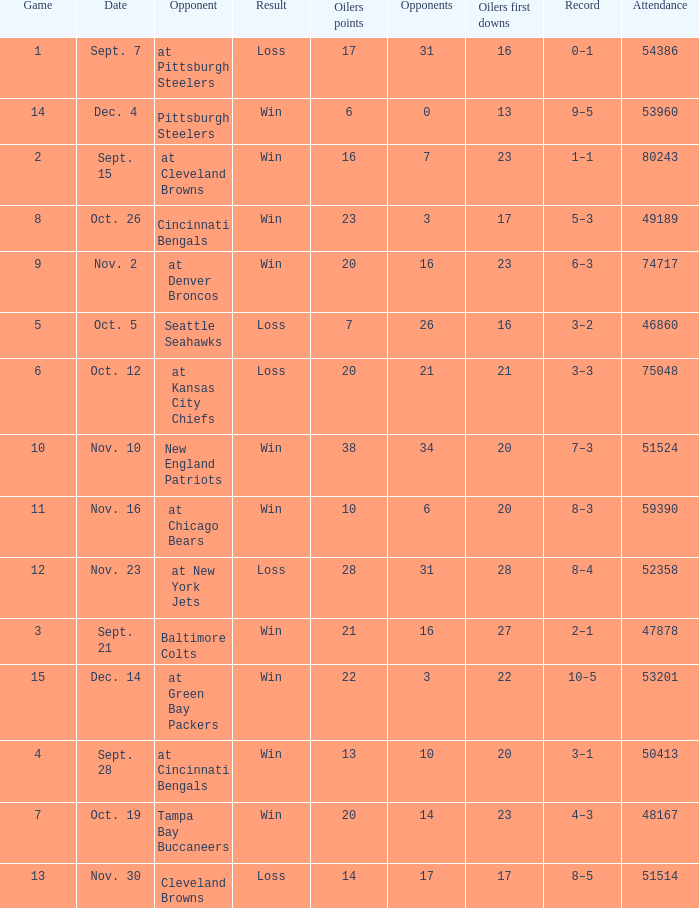Parse the full table. {'header': ['Game', 'Date', 'Opponent', 'Result', 'Oilers points', 'Opponents', 'Oilers first downs', 'Record', 'Attendance'], 'rows': [['1', 'Sept. 7', 'at Pittsburgh Steelers', 'Loss', '17', '31', '16', '0–1', '54386'], ['14', 'Dec. 4', 'Pittsburgh Steelers', 'Win', '6', '0', '13', '9–5', '53960'], ['2', 'Sept. 15', 'at Cleveland Browns', 'Win', '16', '7', '23', '1–1', '80243'], ['8', 'Oct. 26', 'Cincinnati Bengals', 'Win', '23', '3', '17', '5–3', '49189'], ['9', 'Nov. 2', 'at Denver Broncos', 'Win', '20', '16', '23', '6–3', '74717'], ['5', 'Oct. 5', 'Seattle Seahawks', 'Loss', '7', '26', '16', '3–2', '46860'], ['6', 'Oct. 12', 'at Kansas City Chiefs', 'Loss', '20', '21', '21', '3–3', '75048'], ['10', 'Nov. 10', 'New England Patriots', 'Win', '38', '34', '20', '7–3', '51524'], ['11', 'Nov. 16', 'at Chicago Bears', 'Win', '10', '6', '20', '8–3', '59390'], ['12', 'Nov. 23', 'at New York Jets', 'Loss', '28', '31', '28', '8–4', '52358'], ['3', 'Sept. 21', 'Baltimore Colts', 'Win', '21', '16', '27', '2–1', '47878'], ['15', 'Dec. 14', 'at Green Bay Packers', 'Win', '22', '3', '22', '10–5', '53201'], ['4', 'Sept. 28', 'at Cincinnati Bengals', 'Win', '13', '10', '20', '3–1', '50413'], ['7', 'Oct. 19', 'Tampa Bay Buccaneers', 'Win', '20', '14', '23', '4–3', '48167'], ['13', 'Nov. 30', 'Cleveland Browns', 'Loss', '14', '17', '17', '8–5', '51514']]} What was the total opponents points for the game were the Oilers scored 21? 16.0. 